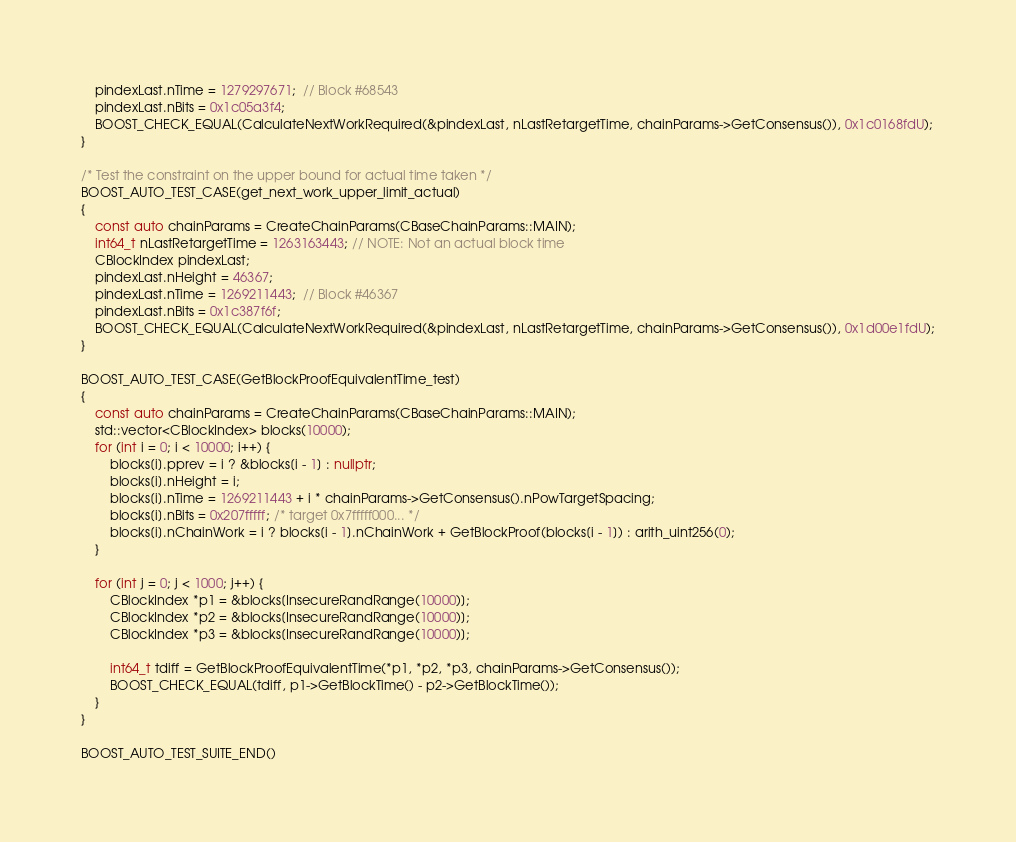<code> <loc_0><loc_0><loc_500><loc_500><_C++_>    pindexLast.nTime = 1279297671;  // Block #68543
    pindexLast.nBits = 0x1c05a3f4;
    BOOST_CHECK_EQUAL(CalculateNextWorkRequired(&pindexLast, nLastRetargetTime, chainParams->GetConsensus()), 0x1c0168fdU);
}

/* Test the constraint on the upper bound for actual time taken */
BOOST_AUTO_TEST_CASE(get_next_work_upper_limit_actual)
{
    const auto chainParams = CreateChainParams(CBaseChainParams::MAIN);
    int64_t nLastRetargetTime = 1263163443; // NOTE: Not an actual block time
    CBlockIndex pindexLast;
    pindexLast.nHeight = 46367;
    pindexLast.nTime = 1269211443;  // Block #46367
    pindexLast.nBits = 0x1c387f6f;
    BOOST_CHECK_EQUAL(CalculateNextWorkRequired(&pindexLast, nLastRetargetTime, chainParams->GetConsensus()), 0x1d00e1fdU);
}

BOOST_AUTO_TEST_CASE(GetBlockProofEquivalentTime_test)
{
    const auto chainParams = CreateChainParams(CBaseChainParams::MAIN);
    std::vector<CBlockIndex> blocks(10000);
    for (int i = 0; i < 10000; i++) {
        blocks[i].pprev = i ? &blocks[i - 1] : nullptr;
        blocks[i].nHeight = i;
        blocks[i].nTime = 1269211443 + i * chainParams->GetConsensus().nPowTargetSpacing;
        blocks[i].nBits = 0x207fffff; /* target 0x7fffff000... */
        blocks[i].nChainWork = i ? blocks[i - 1].nChainWork + GetBlockProof(blocks[i - 1]) : arith_uint256(0);
    }

    for (int j = 0; j < 1000; j++) {
        CBlockIndex *p1 = &blocks[InsecureRandRange(10000)];
        CBlockIndex *p2 = &blocks[InsecureRandRange(10000)];
        CBlockIndex *p3 = &blocks[InsecureRandRange(10000)];

        int64_t tdiff = GetBlockProofEquivalentTime(*p1, *p2, *p3, chainParams->GetConsensus());
        BOOST_CHECK_EQUAL(tdiff, p1->GetBlockTime() - p2->GetBlockTime());
    }
}

BOOST_AUTO_TEST_SUITE_END()
</code> 